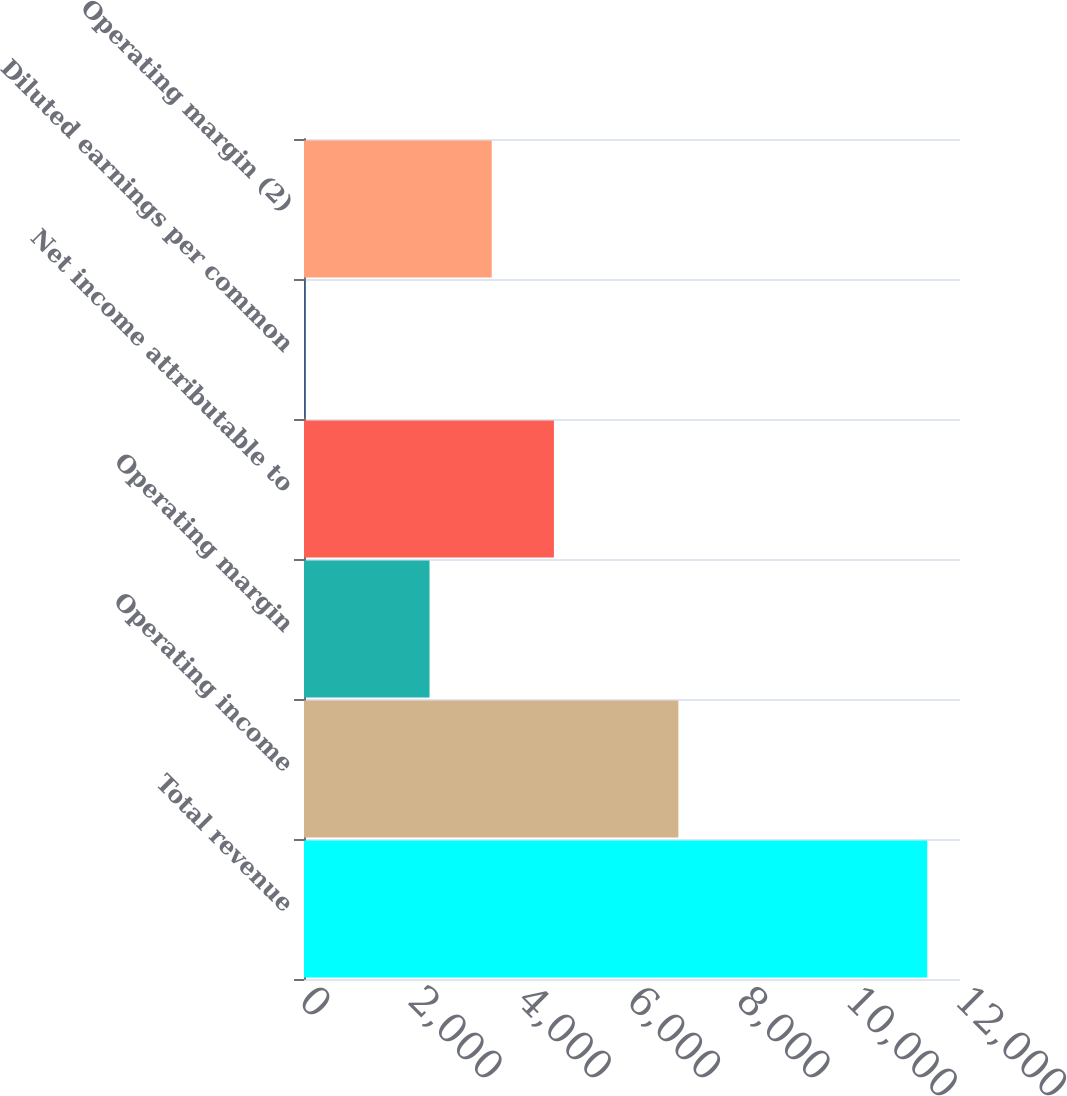Convert chart. <chart><loc_0><loc_0><loc_500><loc_500><bar_chart><fcel>Total revenue<fcel>Operating income<fcel>Operating margin<fcel>Net income attributable to<fcel>Diluted earnings per common<fcel>Operating margin (2)<nl><fcel>11401<fcel>6848.44<fcel>2295.88<fcel>4572.16<fcel>19.6<fcel>3434.02<nl></chart> 